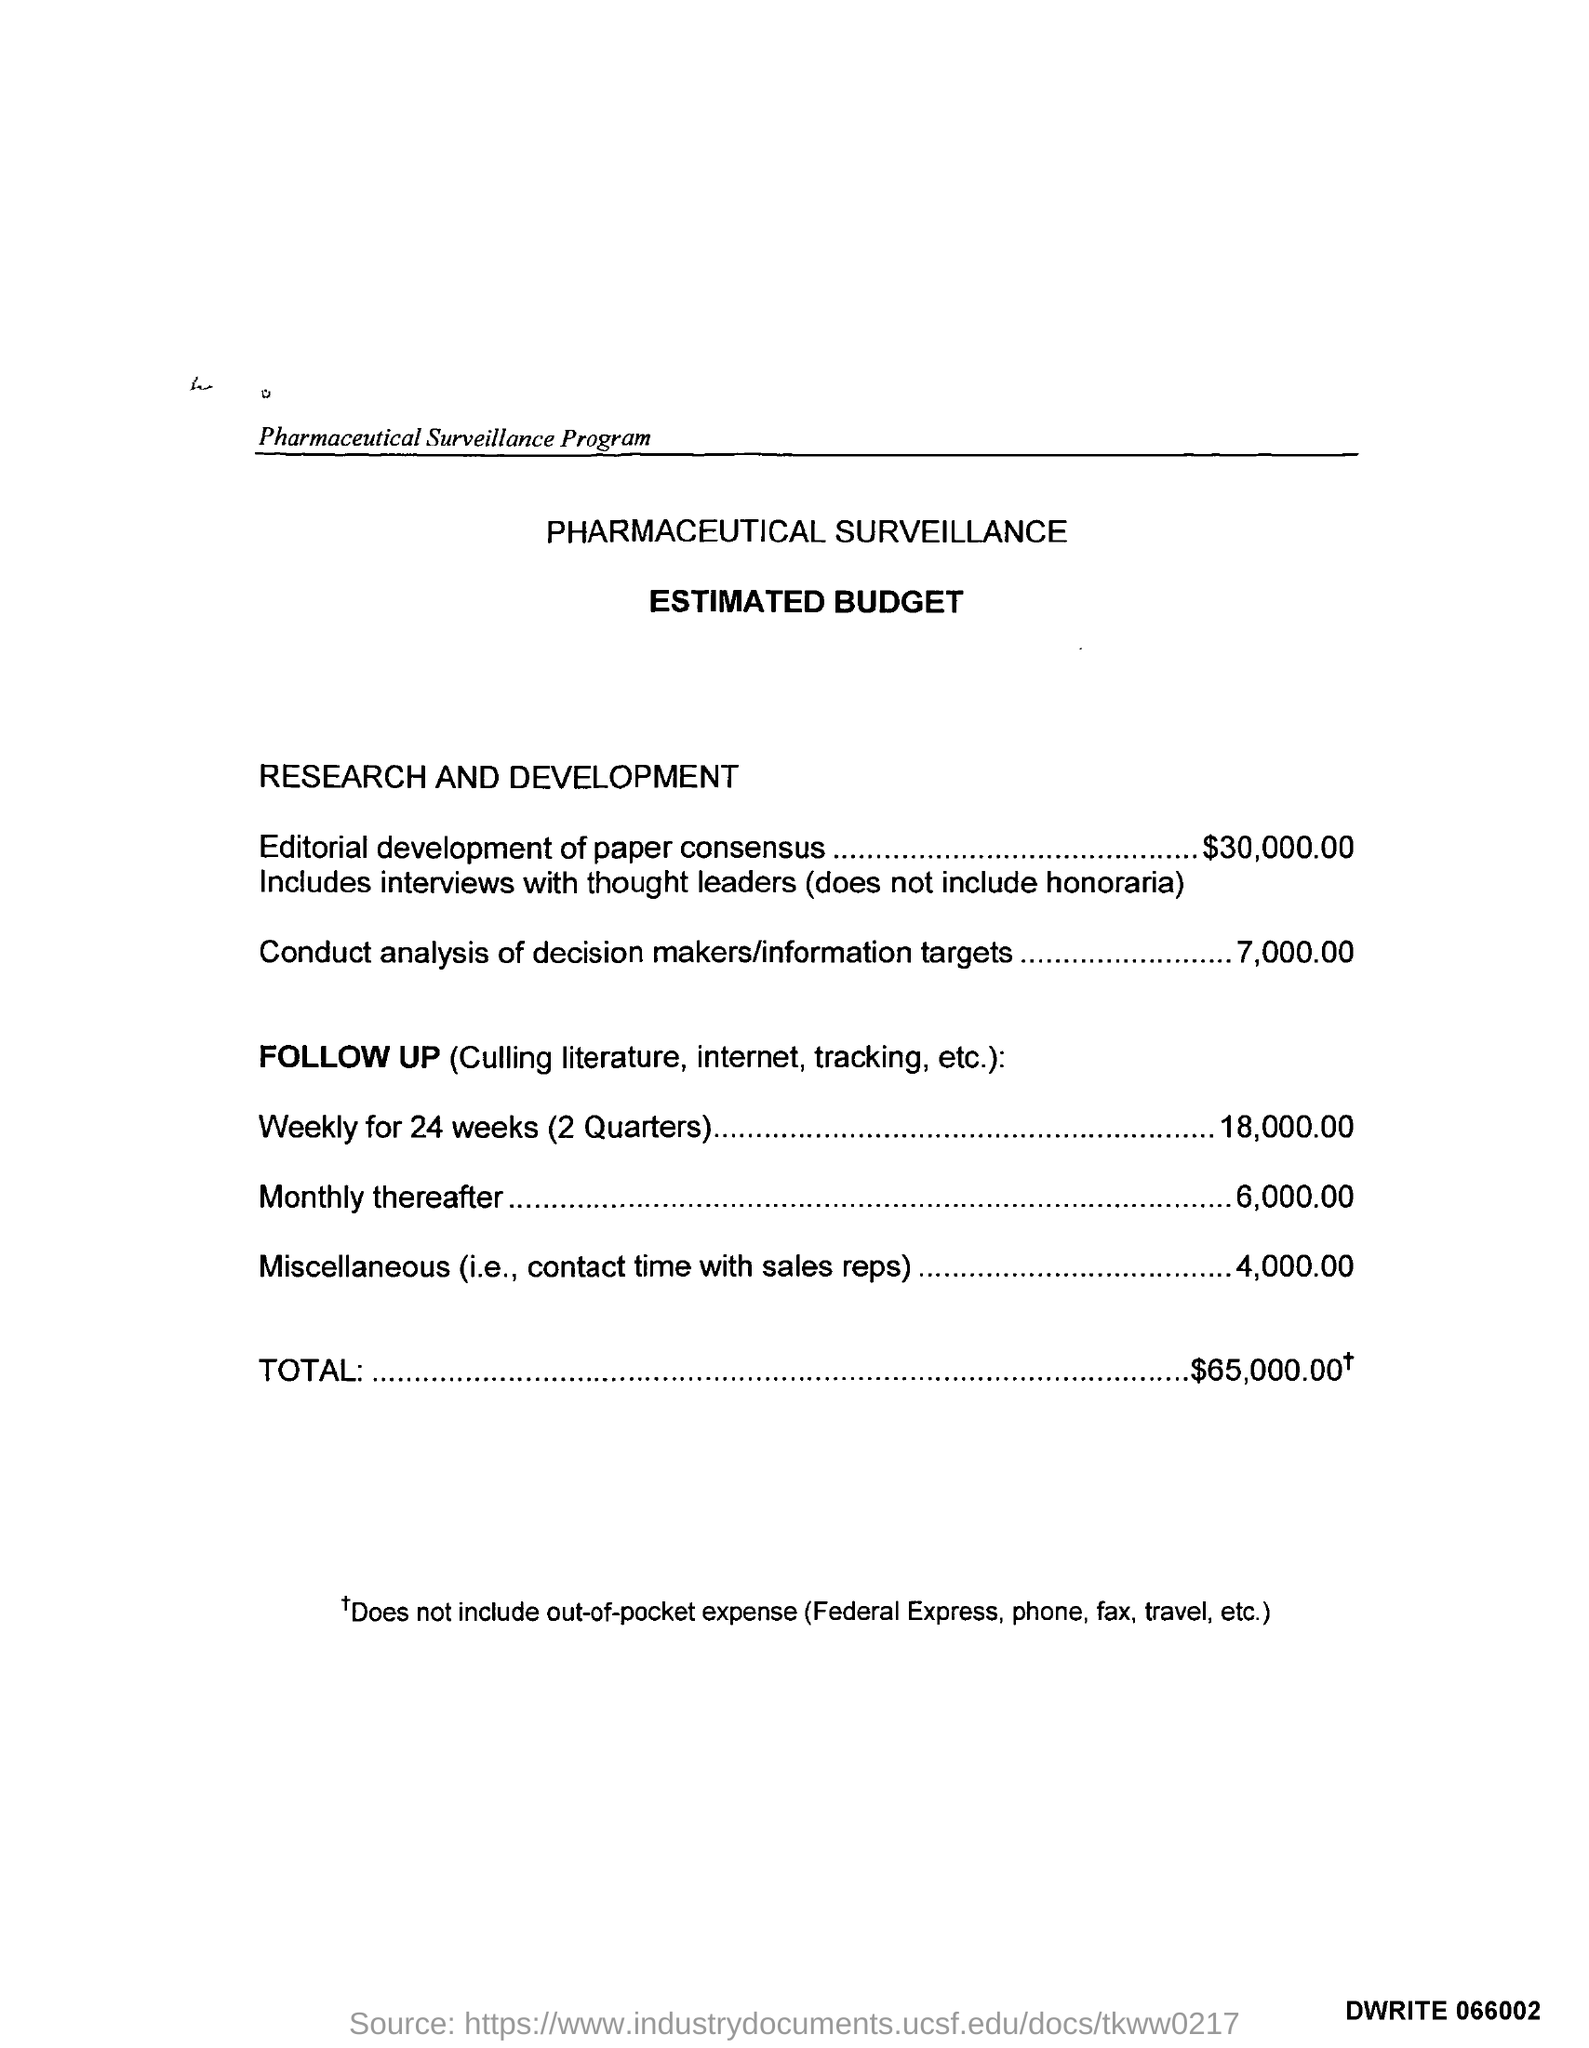What is the estimated budget given for editorial development of paper consensus ?
Provide a succinct answer. $30,000.00. What is the estimated budget given for conduct analysis of decision makers/information targets ?
Provide a short and direct response. 7,000. What is the estimated budget given for miscellaneous (i.e; contact time with sales reps )?
Give a very brief answer. 4,000. What is the estimated budget given for monthly thereafter in the follow up surveillance ?
Make the answer very short. 6,000. What is the estimated budget given for weekly for 24 weeks (2 quarters ) ?
Offer a terse response. 18,000.00. What is the total estimated budget mentioned in the pharmaceutical surveillance ?
Your response must be concise. $ 65,000.00 +. What is the name of the program mentioned in the given page ?
Provide a succinct answer. Pharmaceutical Surveillance Program. 